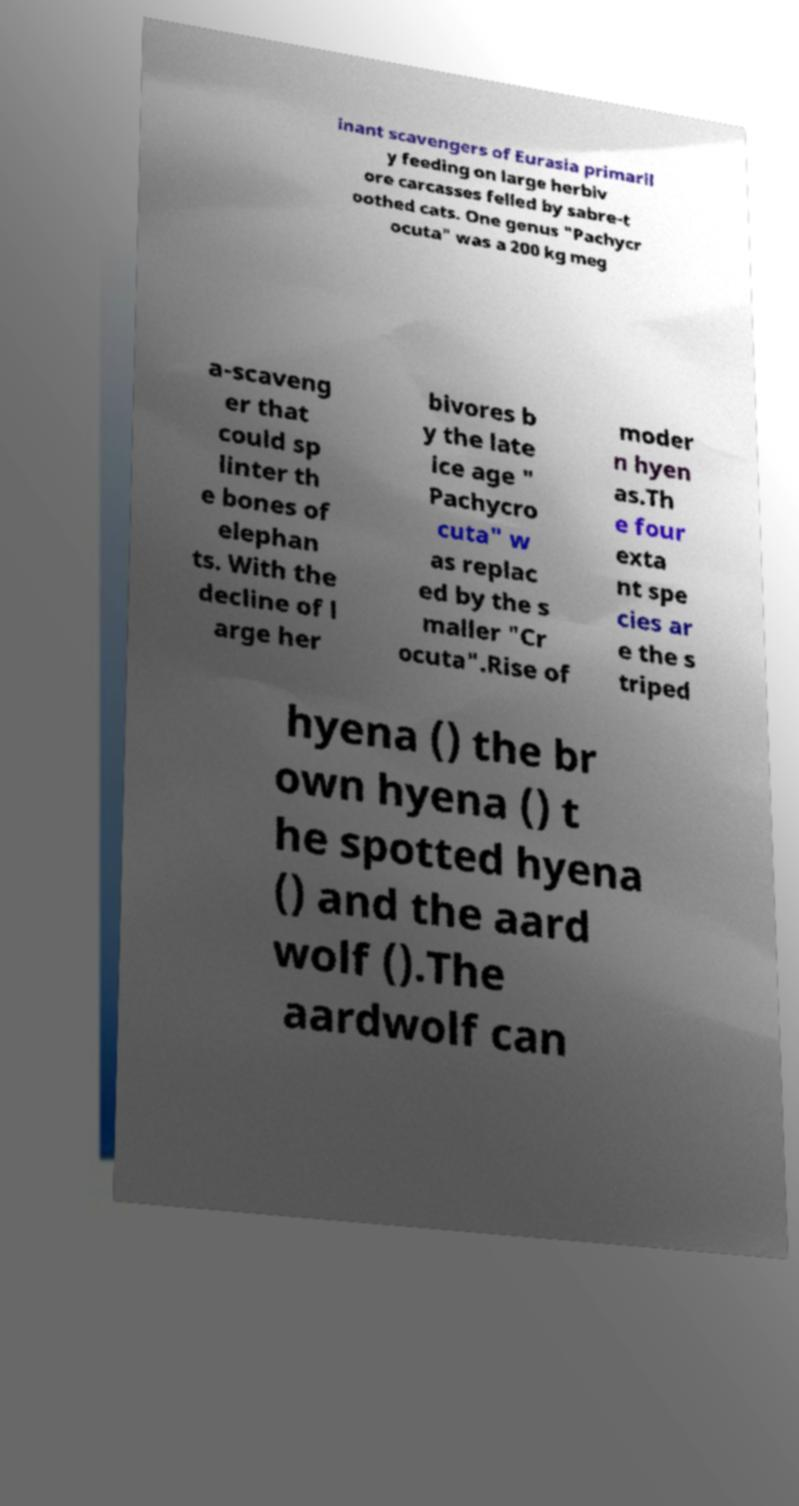Could you assist in decoding the text presented in this image and type it out clearly? inant scavengers of Eurasia primaril y feeding on large herbiv ore carcasses felled by sabre-t oothed cats. One genus "Pachycr ocuta" was a 200 kg meg a-scaveng er that could sp linter th e bones of elephan ts. With the decline of l arge her bivores b y the late ice age " Pachycro cuta" w as replac ed by the s maller "Cr ocuta".Rise of moder n hyen as.Th e four exta nt spe cies ar e the s triped hyena () the br own hyena () t he spotted hyena () and the aard wolf ().The aardwolf can 